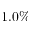Convert formula to latex. <formula><loc_0><loc_0><loc_500><loc_500>1 . 0 \%</formula> 